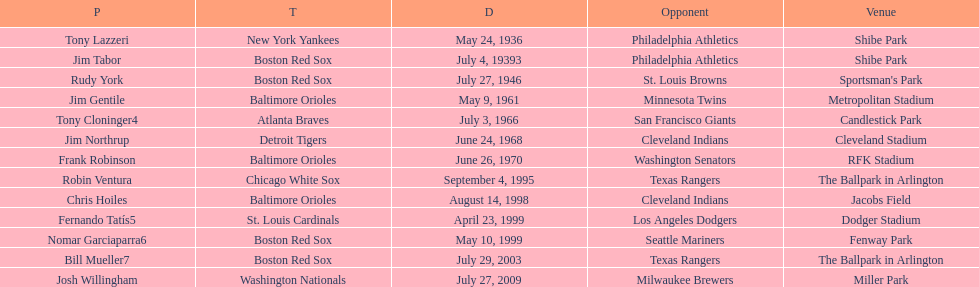Which major league batter was the first to hit two grand slams during a single game? Tony Lazzeri. 